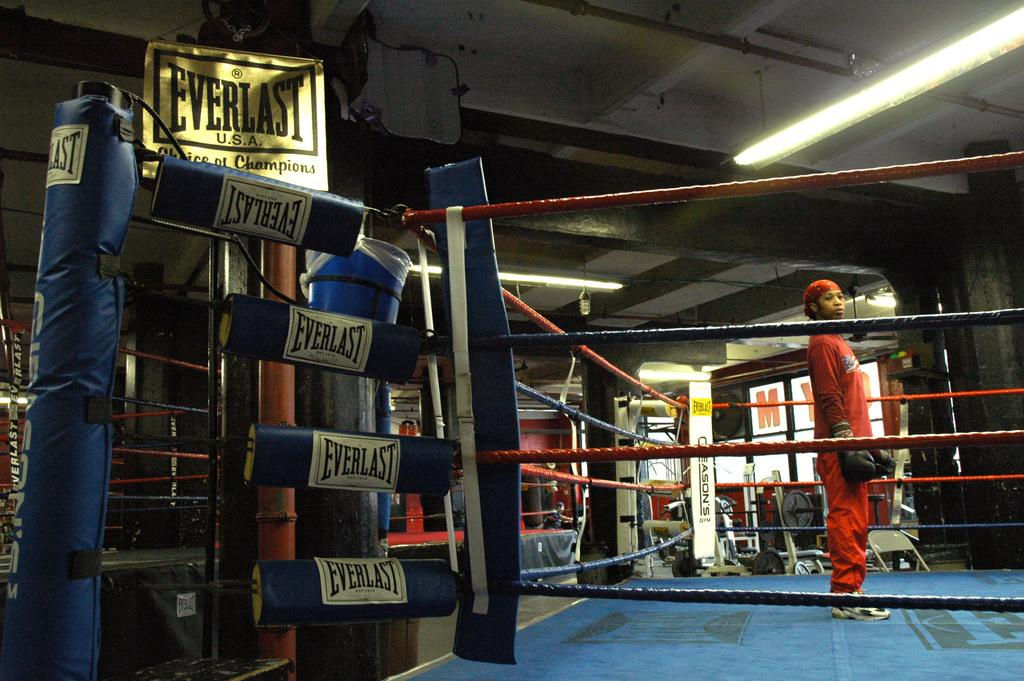<image>
Offer a succinct explanation of the picture presented. female boxer in ring with everlast branded corner padding and everlast sign overhead 